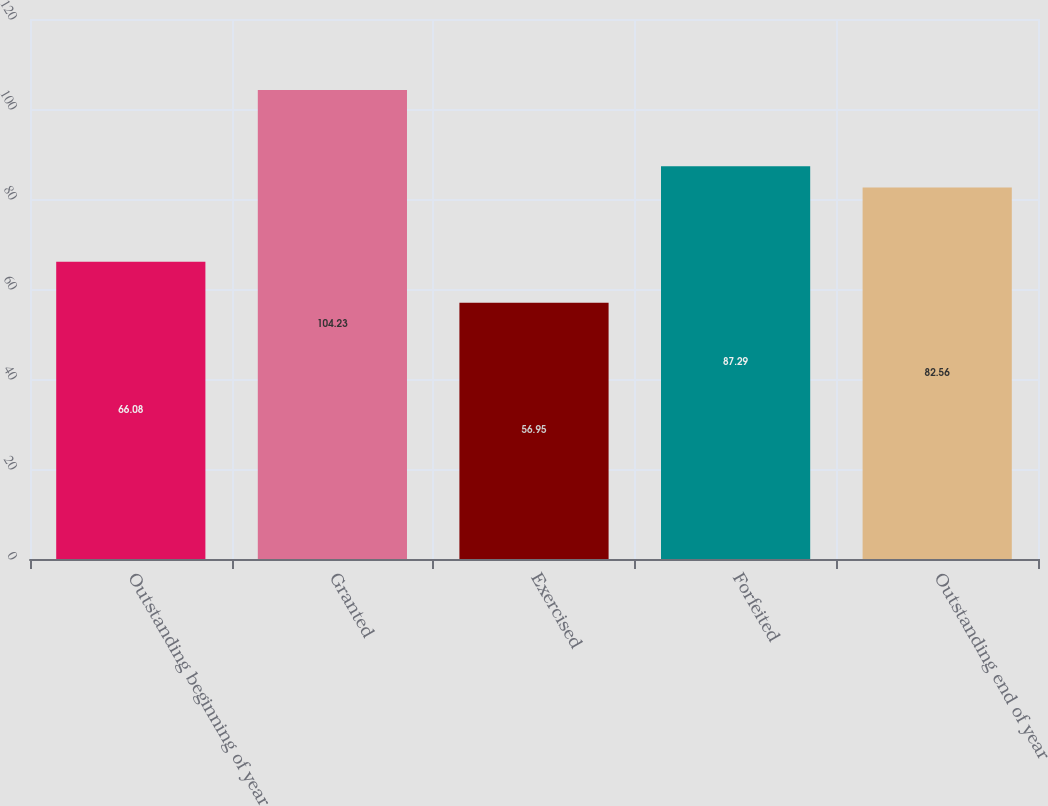Convert chart to OTSL. <chart><loc_0><loc_0><loc_500><loc_500><bar_chart><fcel>Outstanding beginning of year<fcel>Granted<fcel>Exercised<fcel>Forfeited<fcel>Outstanding end of year<nl><fcel>66.08<fcel>104.23<fcel>56.95<fcel>87.29<fcel>82.56<nl></chart> 